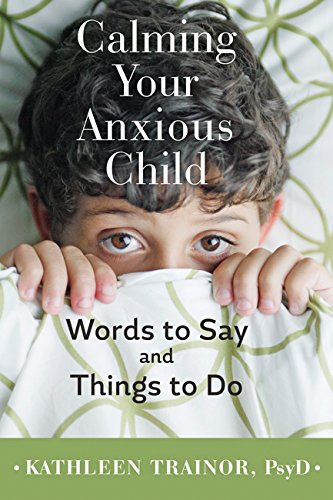What is the genre of this book? This book is categorized under the Self-Help genre, focusing specifically on psychological strategies for reducing anxiety in children. 